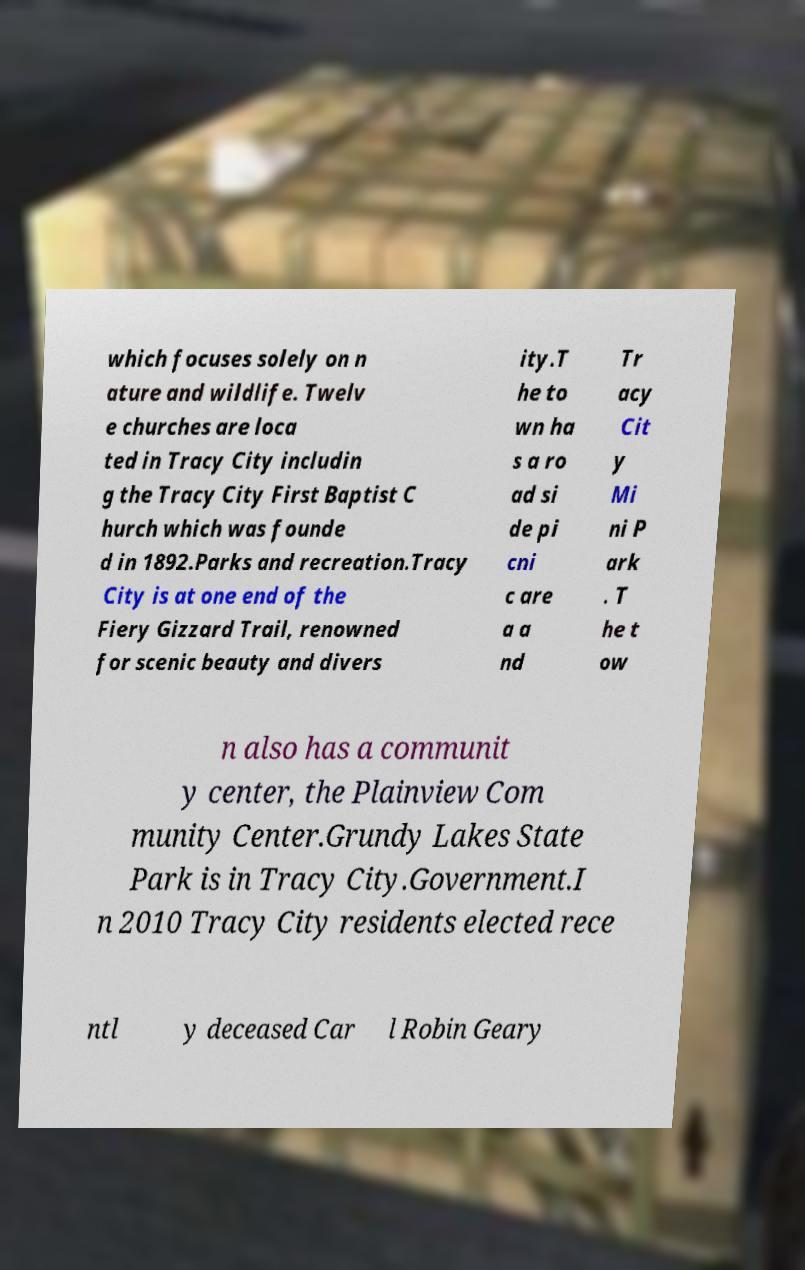I need the written content from this picture converted into text. Can you do that? which focuses solely on n ature and wildlife. Twelv e churches are loca ted in Tracy City includin g the Tracy City First Baptist C hurch which was founde d in 1892.Parks and recreation.Tracy City is at one end of the Fiery Gizzard Trail, renowned for scenic beauty and divers ity.T he to wn ha s a ro ad si de pi cni c are a a nd Tr acy Cit y Mi ni P ark . T he t ow n also has a communit y center, the Plainview Com munity Center.Grundy Lakes State Park is in Tracy City.Government.I n 2010 Tracy City residents elected rece ntl y deceased Car l Robin Geary 